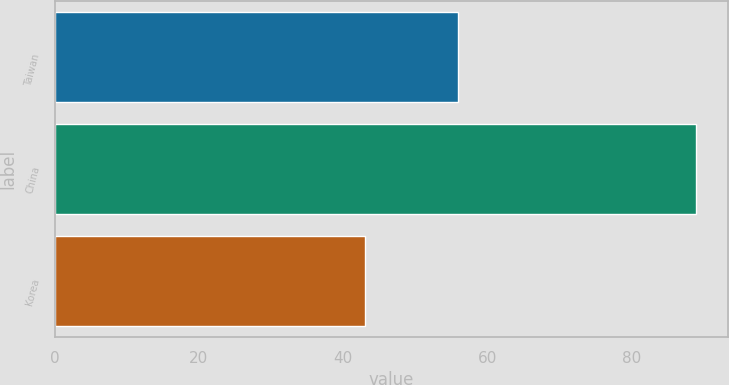Convert chart. <chart><loc_0><loc_0><loc_500><loc_500><bar_chart><fcel>Taiwan<fcel>China<fcel>Korea<nl><fcel>56<fcel>89<fcel>43<nl></chart> 